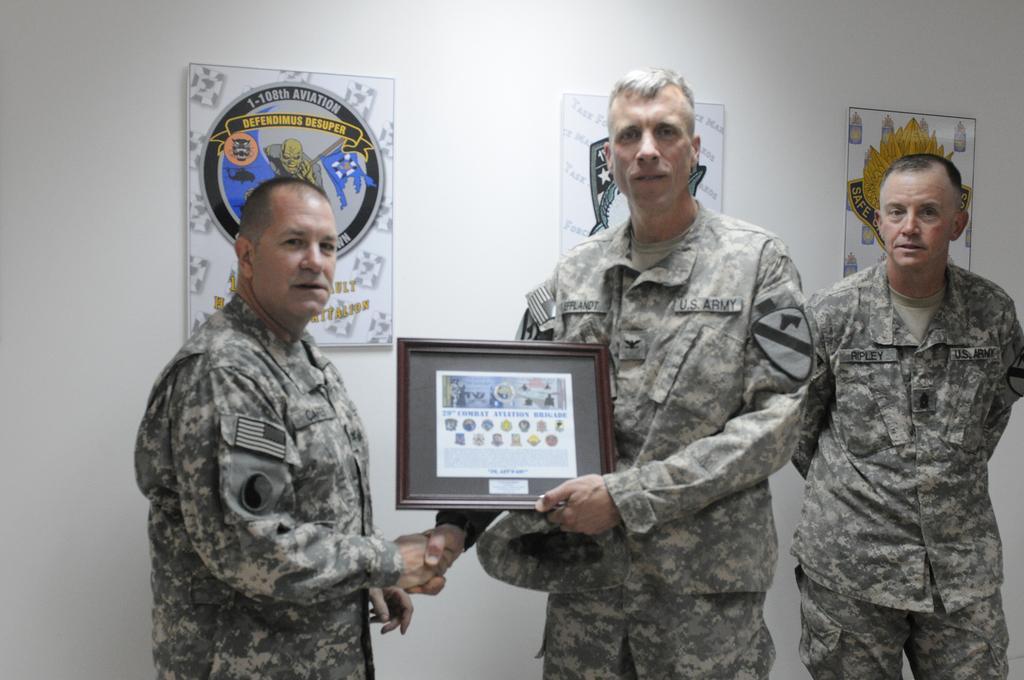Could you give a brief overview of what you see in this image? As we can see in the image in the front there are three people wearing army dresses. The person in the middle is holding a frame. Behind them there is a wall and posters. 